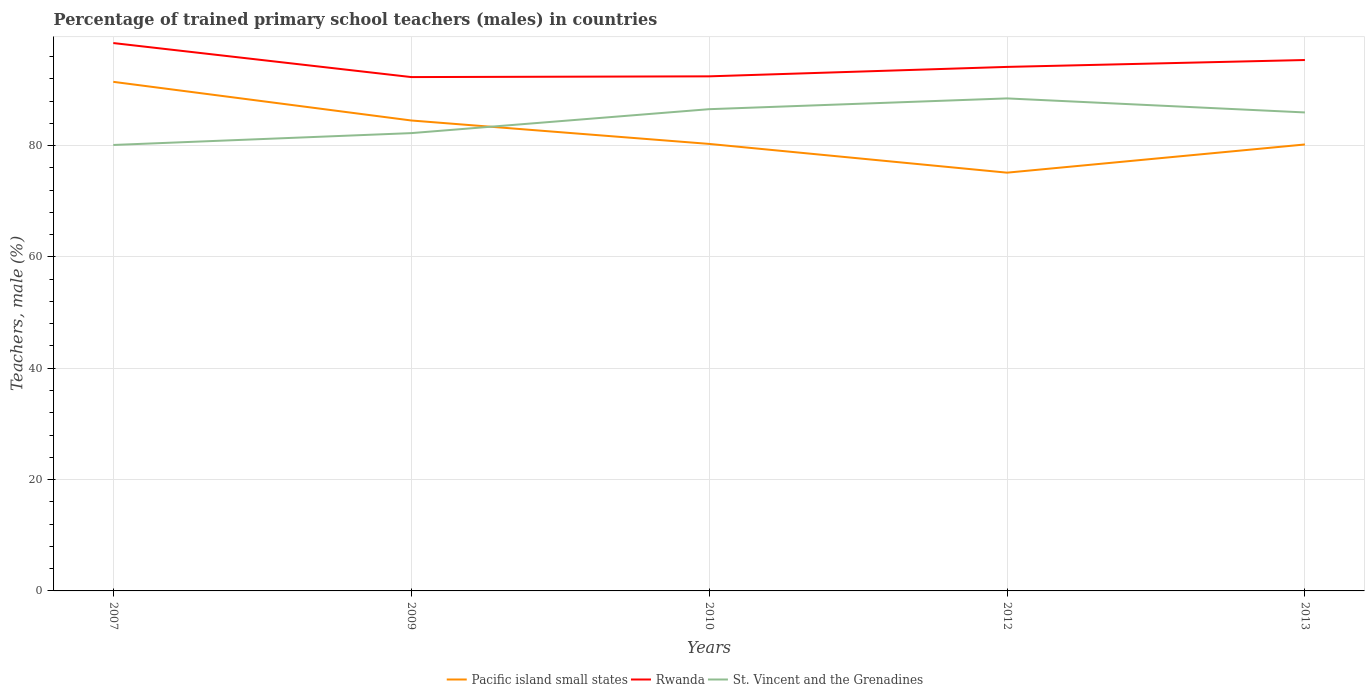How many different coloured lines are there?
Your answer should be compact. 3. Does the line corresponding to St. Vincent and the Grenadines intersect with the line corresponding to Pacific island small states?
Keep it short and to the point. Yes. Across all years, what is the maximum percentage of trained primary school teachers (males) in Rwanda?
Provide a short and direct response. 92.31. In which year was the percentage of trained primary school teachers (males) in Pacific island small states maximum?
Offer a terse response. 2012. What is the total percentage of trained primary school teachers (males) in Pacific island small states in the graph?
Offer a terse response. 4.21. What is the difference between the highest and the second highest percentage of trained primary school teachers (males) in Rwanda?
Keep it short and to the point. 6.11. How many years are there in the graph?
Offer a terse response. 5. What is the difference between two consecutive major ticks on the Y-axis?
Your response must be concise. 20. Does the graph contain any zero values?
Give a very brief answer. No. Does the graph contain grids?
Keep it short and to the point. Yes. How many legend labels are there?
Make the answer very short. 3. How are the legend labels stacked?
Your answer should be very brief. Horizontal. What is the title of the graph?
Give a very brief answer. Percentage of trained primary school teachers (males) in countries. Does "European Union" appear as one of the legend labels in the graph?
Your answer should be very brief. No. What is the label or title of the X-axis?
Provide a succinct answer. Years. What is the label or title of the Y-axis?
Offer a very short reply. Teachers, male (%). What is the Teachers, male (%) in Pacific island small states in 2007?
Your response must be concise. 91.45. What is the Teachers, male (%) in Rwanda in 2007?
Provide a short and direct response. 98.42. What is the Teachers, male (%) in St. Vincent and the Grenadines in 2007?
Make the answer very short. 80.11. What is the Teachers, male (%) in Pacific island small states in 2009?
Provide a short and direct response. 84.51. What is the Teachers, male (%) of Rwanda in 2009?
Offer a terse response. 92.31. What is the Teachers, male (%) of St. Vincent and the Grenadines in 2009?
Give a very brief answer. 82.24. What is the Teachers, male (%) of Pacific island small states in 2010?
Your answer should be very brief. 80.3. What is the Teachers, male (%) in Rwanda in 2010?
Your answer should be very brief. 92.44. What is the Teachers, male (%) in St. Vincent and the Grenadines in 2010?
Give a very brief answer. 86.54. What is the Teachers, male (%) of Pacific island small states in 2012?
Offer a terse response. 75.14. What is the Teachers, male (%) in Rwanda in 2012?
Your answer should be very brief. 94.14. What is the Teachers, male (%) in St. Vincent and the Grenadines in 2012?
Your answer should be compact. 88.48. What is the Teachers, male (%) in Pacific island small states in 2013?
Your response must be concise. 80.2. What is the Teachers, male (%) in Rwanda in 2013?
Ensure brevity in your answer.  95.37. What is the Teachers, male (%) of St. Vincent and the Grenadines in 2013?
Give a very brief answer. 85.96. Across all years, what is the maximum Teachers, male (%) in Pacific island small states?
Your answer should be compact. 91.45. Across all years, what is the maximum Teachers, male (%) of Rwanda?
Ensure brevity in your answer.  98.42. Across all years, what is the maximum Teachers, male (%) in St. Vincent and the Grenadines?
Ensure brevity in your answer.  88.48. Across all years, what is the minimum Teachers, male (%) of Pacific island small states?
Offer a terse response. 75.14. Across all years, what is the minimum Teachers, male (%) of Rwanda?
Make the answer very short. 92.31. Across all years, what is the minimum Teachers, male (%) in St. Vincent and the Grenadines?
Offer a very short reply. 80.11. What is the total Teachers, male (%) in Pacific island small states in the graph?
Offer a terse response. 411.61. What is the total Teachers, male (%) in Rwanda in the graph?
Your answer should be compact. 472.68. What is the total Teachers, male (%) in St. Vincent and the Grenadines in the graph?
Give a very brief answer. 423.33. What is the difference between the Teachers, male (%) of Pacific island small states in 2007 and that in 2009?
Provide a short and direct response. 6.94. What is the difference between the Teachers, male (%) of Rwanda in 2007 and that in 2009?
Provide a short and direct response. 6.11. What is the difference between the Teachers, male (%) of St. Vincent and the Grenadines in 2007 and that in 2009?
Ensure brevity in your answer.  -2.13. What is the difference between the Teachers, male (%) of Pacific island small states in 2007 and that in 2010?
Make the answer very short. 11.15. What is the difference between the Teachers, male (%) in Rwanda in 2007 and that in 2010?
Provide a short and direct response. 5.98. What is the difference between the Teachers, male (%) in St. Vincent and the Grenadines in 2007 and that in 2010?
Provide a short and direct response. -6.43. What is the difference between the Teachers, male (%) in Pacific island small states in 2007 and that in 2012?
Make the answer very short. 16.32. What is the difference between the Teachers, male (%) in Rwanda in 2007 and that in 2012?
Offer a very short reply. 4.29. What is the difference between the Teachers, male (%) of St. Vincent and the Grenadines in 2007 and that in 2012?
Make the answer very short. -8.37. What is the difference between the Teachers, male (%) in Pacific island small states in 2007 and that in 2013?
Offer a terse response. 11.25. What is the difference between the Teachers, male (%) in Rwanda in 2007 and that in 2013?
Make the answer very short. 3.05. What is the difference between the Teachers, male (%) of St. Vincent and the Grenadines in 2007 and that in 2013?
Make the answer very short. -5.84. What is the difference between the Teachers, male (%) of Pacific island small states in 2009 and that in 2010?
Offer a terse response. 4.21. What is the difference between the Teachers, male (%) in Rwanda in 2009 and that in 2010?
Your answer should be compact. -0.13. What is the difference between the Teachers, male (%) of St. Vincent and the Grenadines in 2009 and that in 2010?
Your answer should be compact. -4.3. What is the difference between the Teachers, male (%) in Pacific island small states in 2009 and that in 2012?
Make the answer very short. 9.37. What is the difference between the Teachers, male (%) of Rwanda in 2009 and that in 2012?
Ensure brevity in your answer.  -1.83. What is the difference between the Teachers, male (%) of St. Vincent and the Grenadines in 2009 and that in 2012?
Provide a succinct answer. -6.24. What is the difference between the Teachers, male (%) in Pacific island small states in 2009 and that in 2013?
Your answer should be compact. 4.31. What is the difference between the Teachers, male (%) in Rwanda in 2009 and that in 2013?
Your answer should be very brief. -3.06. What is the difference between the Teachers, male (%) in St. Vincent and the Grenadines in 2009 and that in 2013?
Provide a succinct answer. -3.71. What is the difference between the Teachers, male (%) of Pacific island small states in 2010 and that in 2012?
Your answer should be compact. 5.17. What is the difference between the Teachers, male (%) in Rwanda in 2010 and that in 2012?
Your answer should be compact. -1.69. What is the difference between the Teachers, male (%) of St. Vincent and the Grenadines in 2010 and that in 2012?
Keep it short and to the point. -1.94. What is the difference between the Teachers, male (%) in Pacific island small states in 2010 and that in 2013?
Offer a terse response. 0.1. What is the difference between the Teachers, male (%) in Rwanda in 2010 and that in 2013?
Give a very brief answer. -2.93. What is the difference between the Teachers, male (%) of St. Vincent and the Grenadines in 2010 and that in 2013?
Ensure brevity in your answer.  0.59. What is the difference between the Teachers, male (%) in Pacific island small states in 2012 and that in 2013?
Keep it short and to the point. -5.07. What is the difference between the Teachers, male (%) in Rwanda in 2012 and that in 2013?
Your response must be concise. -1.24. What is the difference between the Teachers, male (%) of St. Vincent and the Grenadines in 2012 and that in 2013?
Keep it short and to the point. 2.52. What is the difference between the Teachers, male (%) in Pacific island small states in 2007 and the Teachers, male (%) in Rwanda in 2009?
Your answer should be very brief. -0.85. What is the difference between the Teachers, male (%) in Pacific island small states in 2007 and the Teachers, male (%) in St. Vincent and the Grenadines in 2009?
Provide a succinct answer. 9.21. What is the difference between the Teachers, male (%) in Rwanda in 2007 and the Teachers, male (%) in St. Vincent and the Grenadines in 2009?
Your answer should be compact. 16.18. What is the difference between the Teachers, male (%) of Pacific island small states in 2007 and the Teachers, male (%) of Rwanda in 2010?
Provide a short and direct response. -0.99. What is the difference between the Teachers, male (%) of Pacific island small states in 2007 and the Teachers, male (%) of St. Vincent and the Grenadines in 2010?
Offer a terse response. 4.91. What is the difference between the Teachers, male (%) of Rwanda in 2007 and the Teachers, male (%) of St. Vincent and the Grenadines in 2010?
Your answer should be compact. 11.88. What is the difference between the Teachers, male (%) in Pacific island small states in 2007 and the Teachers, male (%) in Rwanda in 2012?
Provide a succinct answer. -2.68. What is the difference between the Teachers, male (%) in Pacific island small states in 2007 and the Teachers, male (%) in St. Vincent and the Grenadines in 2012?
Your answer should be compact. 2.98. What is the difference between the Teachers, male (%) in Rwanda in 2007 and the Teachers, male (%) in St. Vincent and the Grenadines in 2012?
Make the answer very short. 9.94. What is the difference between the Teachers, male (%) of Pacific island small states in 2007 and the Teachers, male (%) of Rwanda in 2013?
Make the answer very short. -3.92. What is the difference between the Teachers, male (%) in Pacific island small states in 2007 and the Teachers, male (%) in St. Vincent and the Grenadines in 2013?
Provide a succinct answer. 5.5. What is the difference between the Teachers, male (%) in Rwanda in 2007 and the Teachers, male (%) in St. Vincent and the Grenadines in 2013?
Your answer should be compact. 12.47. What is the difference between the Teachers, male (%) in Pacific island small states in 2009 and the Teachers, male (%) in Rwanda in 2010?
Your answer should be compact. -7.93. What is the difference between the Teachers, male (%) in Pacific island small states in 2009 and the Teachers, male (%) in St. Vincent and the Grenadines in 2010?
Your answer should be very brief. -2.03. What is the difference between the Teachers, male (%) in Rwanda in 2009 and the Teachers, male (%) in St. Vincent and the Grenadines in 2010?
Provide a succinct answer. 5.77. What is the difference between the Teachers, male (%) of Pacific island small states in 2009 and the Teachers, male (%) of Rwanda in 2012?
Your response must be concise. -9.62. What is the difference between the Teachers, male (%) in Pacific island small states in 2009 and the Teachers, male (%) in St. Vincent and the Grenadines in 2012?
Make the answer very short. -3.97. What is the difference between the Teachers, male (%) in Rwanda in 2009 and the Teachers, male (%) in St. Vincent and the Grenadines in 2012?
Provide a short and direct response. 3.83. What is the difference between the Teachers, male (%) of Pacific island small states in 2009 and the Teachers, male (%) of Rwanda in 2013?
Your answer should be very brief. -10.86. What is the difference between the Teachers, male (%) of Pacific island small states in 2009 and the Teachers, male (%) of St. Vincent and the Grenadines in 2013?
Provide a succinct answer. -1.44. What is the difference between the Teachers, male (%) of Rwanda in 2009 and the Teachers, male (%) of St. Vincent and the Grenadines in 2013?
Ensure brevity in your answer.  6.35. What is the difference between the Teachers, male (%) in Pacific island small states in 2010 and the Teachers, male (%) in Rwanda in 2012?
Provide a short and direct response. -13.83. What is the difference between the Teachers, male (%) in Pacific island small states in 2010 and the Teachers, male (%) in St. Vincent and the Grenadines in 2012?
Provide a short and direct response. -8.18. What is the difference between the Teachers, male (%) of Rwanda in 2010 and the Teachers, male (%) of St. Vincent and the Grenadines in 2012?
Offer a terse response. 3.96. What is the difference between the Teachers, male (%) in Pacific island small states in 2010 and the Teachers, male (%) in Rwanda in 2013?
Your answer should be compact. -15.07. What is the difference between the Teachers, male (%) of Pacific island small states in 2010 and the Teachers, male (%) of St. Vincent and the Grenadines in 2013?
Ensure brevity in your answer.  -5.65. What is the difference between the Teachers, male (%) in Rwanda in 2010 and the Teachers, male (%) in St. Vincent and the Grenadines in 2013?
Your answer should be compact. 6.49. What is the difference between the Teachers, male (%) in Pacific island small states in 2012 and the Teachers, male (%) in Rwanda in 2013?
Offer a very short reply. -20.24. What is the difference between the Teachers, male (%) of Pacific island small states in 2012 and the Teachers, male (%) of St. Vincent and the Grenadines in 2013?
Keep it short and to the point. -10.82. What is the difference between the Teachers, male (%) in Rwanda in 2012 and the Teachers, male (%) in St. Vincent and the Grenadines in 2013?
Provide a short and direct response. 8.18. What is the average Teachers, male (%) of Pacific island small states per year?
Your answer should be compact. 82.32. What is the average Teachers, male (%) in Rwanda per year?
Keep it short and to the point. 94.54. What is the average Teachers, male (%) in St. Vincent and the Grenadines per year?
Keep it short and to the point. 84.67. In the year 2007, what is the difference between the Teachers, male (%) of Pacific island small states and Teachers, male (%) of Rwanda?
Make the answer very short. -6.97. In the year 2007, what is the difference between the Teachers, male (%) of Pacific island small states and Teachers, male (%) of St. Vincent and the Grenadines?
Provide a short and direct response. 11.34. In the year 2007, what is the difference between the Teachers, male (%) in Rwanda and Teachers, male (%) in St. Vincent and the Grenadines?
Make the answer very short. 18.31. In the year 2009, what is the difference between the Teachers, male (%) of Pacific island small states and Teachers, male (%) of Rwanda?
Make the answer very short. -7.8. In the year 2009, what is the difference between the Teachers, male (%) of Pacific island small states and Teachers, male (%) of St. Vincent and the Grenadines?
Keep it short and to the point. 2.27. In the year 2009, what is the difference between the Teachers, male (%) in Rwanda and Teachers, male (%) in St. Vincent and the Grenadines?
Your response must be concise. 10.07. In the year 2010, what is the difference between the Teachers, male (%) of Pacific island small states and Teachers, male (%) of Rwanda?
Your answer should be compact. -12.14. In the year 2010, what is the difference between the Teachers, male (%) of Pacific island small states and Teachers, male (%) of St. Vincent and the Grenadines?
Make the answer very short. -6.24. In the year 2010, what is the difference between the Teachers, male (%) in Rwanda and Teachers, male (%) in St. Vincent and the Grenadines?
Offer a very short reply. 5.9. In the year 2012, what is the difference between the Teachers, male (%) of Pacific island small states and Teachers, male (%) of Rwanda?
Your answer should be compact. -19. In the year 2012, what is the difference between the Teachers, male (%) in Pacific island small states and Teachers, male (%) in St. Vincent and the Grenadines?
Offer a very short reply. -13.34. In the year 2012, what is the difference between the Teachers, male (%) of Rwanda and Teachers, male (%) of St. Vincent and the Grenadines?
Offer a very short reply. 5.66. In the year 2013, what is the difference between the Teachers, male (%) of Pacific island small states and Teachers, male (%) of Rwanda?
Offer a terse response. -15.17. In the year 2013, what is the difference between the Teachers, male (%) of Pacific island small states and Teachers, male (%) of St. Vincent and the Grenadines?
Provide a short and direct response. -5.75. In the year 2013, what is the difference between the Teachers, male (%) in Rwanda and Teachers, male (%) in St. Vincent and the Grenadines?
Your answer should be very brief. 9.42. What is the ratio of the Teachers, male (%) in Pacific island small states in 2007 to that in 2009?
Offer a terse response. 1.08. What is the ratio of the Teachers, male (%) in Rwanda in 2007 to that in 2009?
Provide a succinct answer. 1.07. What is the ratio of the Teachers, male (%) of St. Vincent and the Grenadines in 2007 to that in 2009?
Provide a succinct answer. 0.97. What is the ratio of the Teachers, male (%) of Pacific island small states in 2007 to that in 2010?
Make the answer very short. 1.14. What is the ratio of the Teachers, male (%) in Rwanda in 2007 to that in 2010?
Ensure brevity in your answer.  1.06. What is the ratio of the Teachers, male (%) of St. Vincent and the Grenadines in 2007 to that in 2010?
Give a very brief answer. 0.93. What is the ratio of the Teachers, male (%) in Pacific island small states in 2007 to that in 2012?
Your answer should be very brief. 1.22. What is the ratio of the Teachers, male (%) in Rwanda in 2007 to that in 2012?
Your response must be concise. 1.05. What is the ratio of the Teachers, male (%) of St. Vincent and the Grenadines in 2007 to that in 2012?
Keep it short and to the point. 0.91. What is the ratio of the Teachers, male (%) of Pacific island small states in 2007 to that in 2013?
Offer a very short reply. 1.14. What is the ratio of the Teachers, male (%) of Rwanda in 2007 to that in 2013?
Ensure brevity in your answer.  1.03. What is the ratio of the Teachers, male (%) of St. Vincent and the Grenadines in 2007 to that in 2013?
Provide a succinct answer. 0.93. What is the ratio of the Teachers, male (%) in Pacific island small states in 2009 to that in 2010?
Offer a terse response. 1.05. What is the ratio of the Teachers, male (%) of St. Vincent and the Grenadines in 2009 to that in 2010?
Offer a very short reply. 0.95. What is the ratio of the Teachers, male (%) of Pacific island small states in 2009 to that in 2012?
Offer a terse response. 1.12. What is the ratio of the Teachers, male (%) in Rwanda in 2009 to that in 2012?
Make the answer very short. 0.98. What is the ratio of the Teachers, male (%) in St. Vincent and the Grenadines in 2009 to that in 2012?
Your response must be concise. 0.93. What is the ratio of the Teachers, male (%) of Pacific island small states in 2009 to that in 2013?
Your answer should be very brief. 1.05. What is the ratio of the Teachers, male (%) of Rwanda in 2009 to that in 2013?
Ensure brevity in your answer.  0.97. What is the ratio of the Teachers, male (%) of St. Vincent and the Grenadines in 2009 to that in 2013?
Your answer should be compact. 0.96. What is the ratio of the Teachers, male (%) of Pacific island small states in 2010 to that in 2012?
Provide a succinct answer. 1.07. What is the ratio of the Teachers, male (%) in St. Vincent and the Grenadines in 2010 to that in 2012?
Offer a terse response. 0.98. What is the ratio of the Teachers, male (%) of Rwanda in 2010 to that in 2013?
Your answer should be compact. 0.97. What is the ratio of the Teachers, male (%) in St. Vincent and the Grenadines in 2010 to that in 2013?
Offer a very short reply. 1.01. What is the ratio of the Teachers, male (%) in Pacific island small states in 2012 to that in 2013?
Keep it short and to the point. 0.94. What is the ratio of the Teachers, male (%) of St. Vincent and the Grenadines in 2012 to that in 2013?
Keep it short and to the point. 1.03. What is the difference between the highest and the second highest Teachers, male (%) of Pacific island small states?
Offer a very short reply. 6.94. What is the difference between the highest and the second highest Teachers, male (%) in Rwanda?
Your answer should be very brief. 3.05. What is the difference between the highest and the second highest Teachers, male (%) in St. Vincent and the Grenadines?
Your answer should be compact. 1.94. What is the difference between the highest and the lowest Teachers, male (%) of Pacific island small states?
Keep it short and to the point. 16.32. What is the difference between the highest and the lowest Teachers, male (%) of Rwanda?
Offer a terse response. 6.11. What is the difference between the highest and the lowest Teachers, male (%) in St. Vincent and the Grenadines?
Make the answer very short. 8.37. 